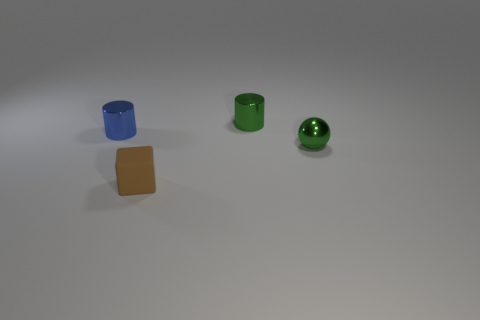What number of tiny objects are the same material as the sphere?
Your answer should be compact. 2. What number of objects are either big blue metallic spheres or objects right of the small brown rubber cube?
Give a very brief answer. 2. The object that is in front of the tiny green shiny object that is in front of the green object that is left of the metallic sphere is what color?
Provide a succinct answer. Brown. There is a metallic cylinder that is on the left side of the green metal cylinder; what size is it?
Keep it short and to the point. Small. How many large things are cylinders or rubber cubes?
Your answer should be very brief. 0. There is a object that is both in front of the blue metal thing and behind the rubber cube; what is its color?
Make the answer very short. Green. Are there any other brown objects that have the same shape as the small brown object?
Offer a terse response. No. What is the tiny blue thing made of?
Provide a short and direct response. Metal. There is a small ball; are there any tiny green metallic things left of it?
Your answer should be compact. Yes. Does the small brown rubber thing have the same shape as the blue object?
Give a very brief answer. No. 